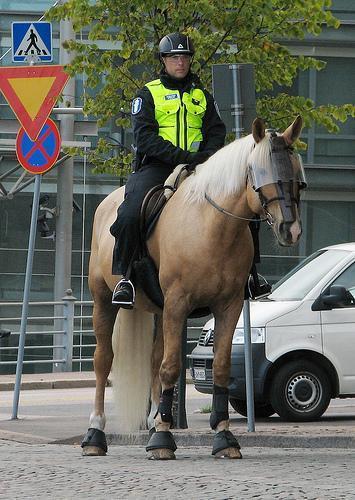How many animals are there?
Give a very brief answer. 1. How many people are there?
Give a very brief answer. 1. How many signs are there?
Give a very brief answer. 3. How many firemen are on the horse?
Give a very brief answer. 0. 